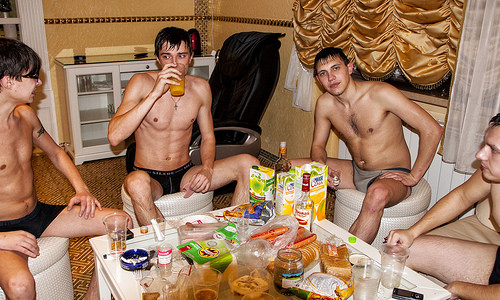<image>
Is there a chair behind the man? Yes. From this viewpoint, the chair is positioned behind the man, with the man partially or fully occluding the chair. Is there a chair next to the cup? No. The chair is not positioned next to the cup. They are located in different areas of the scene. 